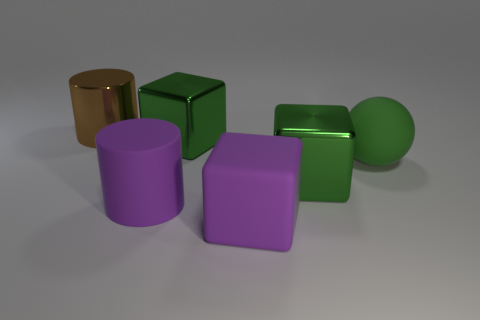Subtract all cyan spheres. How many green blocks are left? 2 Subtract all large green cubes. How many cubes are left? 1 Add 1 purple blocks. How many objects exist? 7 Subtract all balls. How many objects are left? 5 Add 5 green balls. How many green balls exist? 6 Subtract 0 yellow balls. How many objects are left? 6 Subtract all large shiny things. Subtract all green spheres. How many objects are left? 2 Add 2 big metal cylinders. How many big metal cylinders are left? 3 